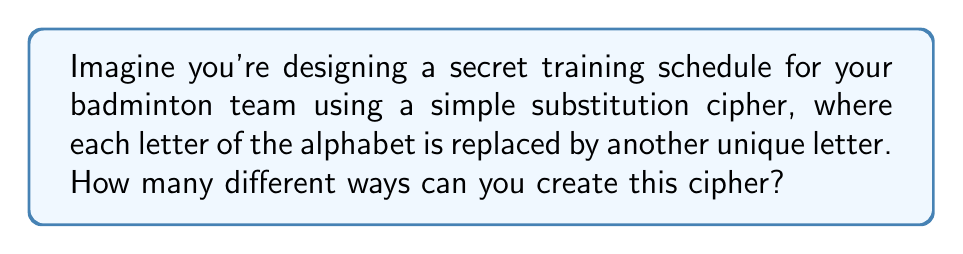Solve this math problem. To solve this problem, we need to understand the concept of permutations in a simple substitution cipher. Here's a step-by-step explanation:

1. In a simple substitution cipher, each letter of the alphabet is replaced by another unique letter.

2. We have 26 letters in the English alphabet.

3. For the first letter, we have 26 choices.

4. For the second letter, we have 25 choices (since one letter has already been used).

5. For the third letter, we have 24 choices, and so on.

6. This pattern continues until we reach the last letter, which has only 1 choice left.

7. The total number of permutations is the product of all these choices:

   $$26 \times 25 \times 24 \times 23 \times ... \times 2 \times 1$$

8. This is equivalent to the factorial of 26, written as 26!

9. We can calculate this as:

   $$26! = 403,291,461,126,605,635,584,000,000$$

Therefore, there are 26! different ways to create a simple substitution cipher for your badminton team's secret training schedule.
Answer: 26! 